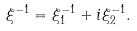<formula> <loc_0><loc_0><loc_500><loc_500>\xi ^ { - 1 } = \xi _ { 1 } ^ { - 1 } + i \xi _ { 2 } ^ { - 1 } .</formula> 